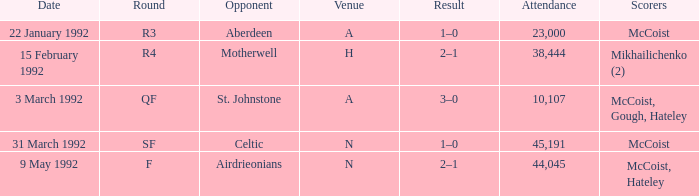What outcome occurs when there are more than 10,107 attendees and celtic is the opposing team? 1–0. 